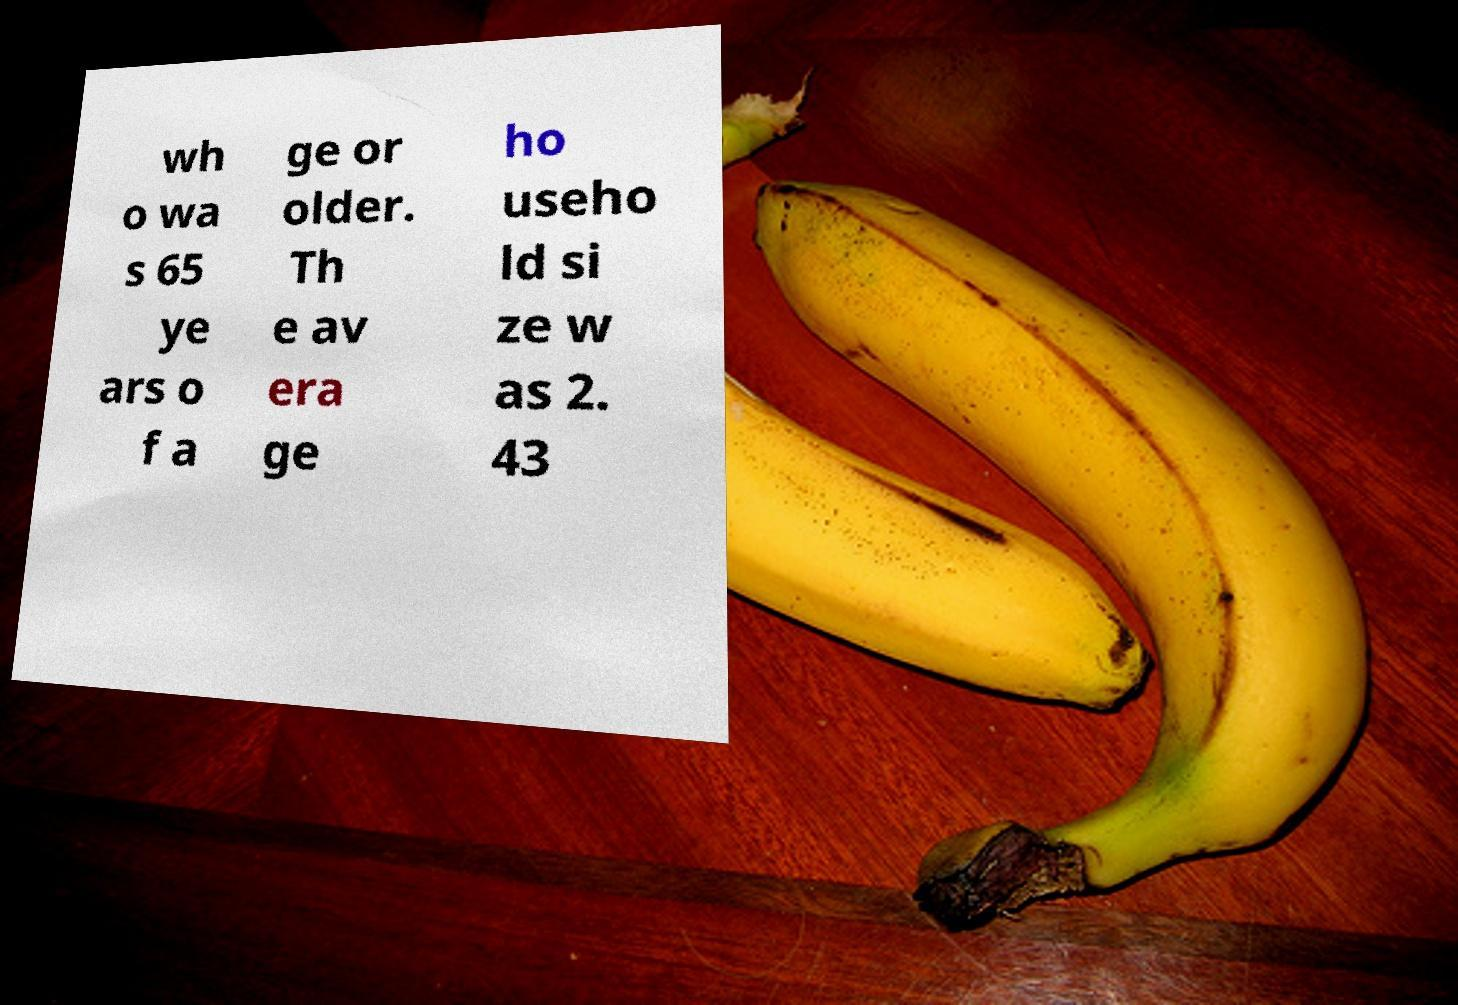Could you extract and type out the text from this image? wh o wa s 65 ye ars o f a ge or older. Th e av era ge ho useho ld si ze w as 2. 43 